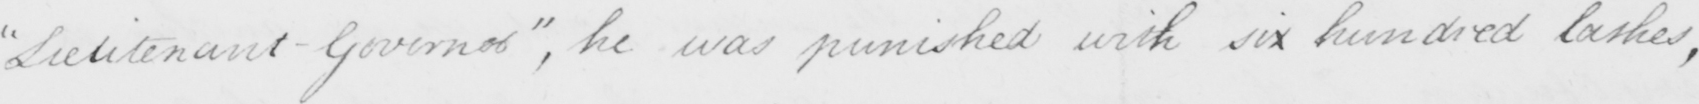What is written in this line of handwriting? " Lieutenant Governor "  , he was punished with six hundred lashes , 